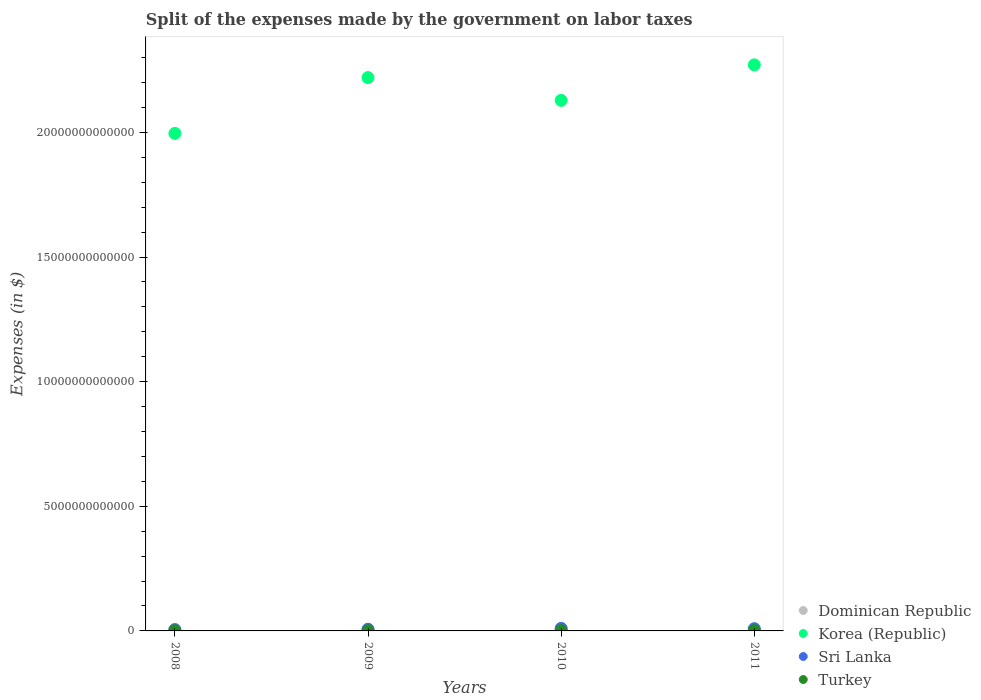Is the number of dotlines equal to the number of legend labels?
Keep it short and to the point. Yes. What is the expenses made by the government on labor taxes in Sri Lanka in 2010?
Your answer should be very brief. 1.03e+11. Across all years, what is the maximum expenses made by the government on labor taxes in Korea (Republic)?
Keep it short and to the point. 2.27e+13. Across all years, what is the minimum expenses made by the government on labor taxes in Turkey?
Offer a very short reply. 8.59e+09. In which year was the expenses made by the government on labor taxes in Dominican Republic maximum?
Provide a succinct answer. 2011. In which year was the expenses made by the government on labor taxes in Korea (Republic) minimum?
Offer a terse response. 2008. What is the total expenses made by the government on labor taxes in Korea (Republic) in the graph?
Provide a succinct answer. 8.62e+13. What is the difference between the expenses made by the government on labor taxes in Korea (Republic) in 2010 and that in 2011?
Provide a short and direct response. -1.42e+12. What is the difference between the expenses made by the government on labor taxes in Sri Lanka in 2011 and the expenses made by the government on labor taxes in Korea (Republic) in 2008?
Ensure brevity in your answer.  -1.99e+13. What is the average expenses made by the government on labor taxes in Dominican Republic per year?
Give a very brief answer. 1.30e+1. In the year 2010, what is the difference between the expenses made by the government on labor taxes in Korea (Republic) and expenses made by the government on labor taxes in Dominican Republic?
Provide a short and direct response. 2.13e+13. In how many years, is the expenses made by the government on labor taxes in Sri Lanka greater than 14000000000000 $?
Ensure brevity in your answer.  0. What is the ratio of the expenses made by the government on labor taxes in Sri Lanka in 2008 to that in 2009?
Offer a terse response. 0.78. Is the expenses made by the government on labor taxes in Korea (Republic) in 2009 less than that in 2011?
Offer a very short reply. Yes. What is the difference between the highest and the second highest expenses made by the government on labor taxes in Dominican Republic?
Your response must be concise. 2.41e+09. What is the difference between the highest and the lowest expenses made by the government on labor taxes in Sri Lanka?
Offer a terse response. 4.86e+1. Is it the case that in every year, the sum of the expenses made by the government on labor taxes in Sri Lanka and expenses made by the government on labor taxes in Dominican Republic  is greater than the sum of expenses made by the government on labor taxes in Korea (Republic) and expenses made by the government on labor taxes in Turkey?
Give a very brief answer. Yes. Is it the case that in every year, the sum of the expenses made by the government on labor taxes in Turkey and expenses made by the government on labor taxes in Sri Lanka  is greater than the expenses made by the government on labor taxes in Korea (Republic)?
Provide a succinct answer. No. Does the expenses made by the government on labor taxes in Turkey monotonically increase over the years?
Your answer should be very brief. No. How many dotlines are there?
Make the answer very short. 4. How many years are there in the graph?
Offer a very short reply. 4. What is the difference between two consecutive major ticks on the Y-axis?
Ensure brevity in your answer.  5.00e+12. Are the values on the major ticks of Y-axis written in scientific E-notation?
Make the answer very short. No. Does the graph contain any zero values?
Offer a terse response. No. How are the legend labels stacked?
Give a very brief answer. Vertical. What is the title of the graph?
Offer a very short reply. Split of the expenses made by the government on labor taxes. What is the label or title of the X-axis?
Your response must be concise. Years. What is the label or title of the Y-axis?
Provide a succinct answer. Expenses (in $). What is the Expenses (in $) in Dominican Republic in 2008?
Give a very brief answer. 1.22e+1. What is the Expenses (in $) in Korea (Republic) in 2008?
Offer a very short reply. 2.00e+13. What is the Expenses (in $) in Sri Lanka in 2008?
Your answer should be compact. 5.44e+1. What is the Expenses (in $) of Turkey in 2008?
Your response must be concise. 8.59e+09. What is the Expenses (in $) in Dominican Republic in 2009?
Your answer should be very brief. 1.09e+1. What is the Expenses (in $) of Korea (Republic) in 2009?
Ensure brevity in your answer.  2.22e+13. What is the Expenses (in $) of Sri Lanka in 2009?
Keep it short and to the point. 6.97e+1. What is the Expenses (in $) of Turkey in 2009?
Provide a succinct answer. 1.01e+1. What is the Expenses (in $) of Dominican Republic in 2010?
Offer a terse response. 1.32e+1. What is the Expenses (in $) of Korea (Republic) in 2010?
Ensure brevity in your answer.  2.13e+13. What is the Expenses (in $) in Sri Lanka in 2010?
Provide a short and direct response. 1.03e+11. What is the Expenses (in $) in Turkey in 2010?
Offer a very short reply. 1.50e+1. What is the Expenses (in $) of Dominican Republic in 2011?
Your response must be concise. 1.57e+1. What is the Expenses (in $) of Korea (Republic) in 2011?
Offer a very short reply. 2.27e+13. What is the Expenses (in $) in Sri Lanka in 2011?
Your response must be concise. 8.96e+1. What is the Expenses (in $) of Turkey in 2011?
Your answer should be compact. 1.15e+1. Across all years, what is the maximum Expenses (in $) in Dominican Republic?
Give a very brief answer. 1.57e+1. Across all years, what is the maximum Expenses (in $) of Korea (Republic)?
Your answer should be very brief. 2.27e+13. Across all years, what is the maximum Expenses (in $) in Sri Lanka?
Keep it short and to the point. 1.03e+11. Across all years, what is the maximum Expenses (in $) of Turkey?
Your answer should be compact. 1.50e+1. Across all years, what is the minimum Expenses (in $) of Dominican Republic?
Make the answer very short. 1.09e+1. Across all years, what is the minimum Expenses (in $) of Korea (Republic)?
Offer a very short reply. 2.00e+13. Across all years, what is the minimum Expenses (in $) of Sri Lanka?
Provide a succinct answer. 5.44e+1. Across all years, what is the minimum Expenses (in $) of Turkey?
Provide a short and direct response. 8.59e+09. What is the total Expenses (in $) of Dominican Republic in the graph?
Give a very brief answer. 5.20e+1. What is the total Expenses (in $) in Korea (Republic) in the graph?
Offer a very short reply. 8.62e+13. What is the total Expenses (in $) of Sri Lanka in the graph?
Offer a terse response. 3.17e+11. What is the total Expenses (in $) of Turkey in the graph?
Your answer should be very brief. 4.52e+1. What is the difference between the Expenses (in $) in Dominican Republic in 2008 and that in 2009?
Offer a very short reply. 1.29e+09. What is the difference between the Expenses (in $) of Korea (Republic) in 2008 and that in 2009?
Offer a very short reply. -2.24e+12. What is the difference between the Expenses (in $) of Sri Lanka in 2008 and that in 2009?
Your answer should be very brief. -1.53e+1. What is the difference between the Expenses (in $) in Turkey in 2008 and that in 2009?
Give a very brief answer. -1.55e+09. What is the difference between the Expenses (in $) of Dominican Republic in 2008 and that in 2010?
Offer a very short reply. -1.07e+09. What is the difference between the Expenses (in $) in Korea (Republic) in 2008 and that in 2010?
Offer a very short reply. -1.33e+12. What is the difference between the Expenses (in $) of Sri Lanka in 2008 and that in 2010?
Provide a short and direct response. -4.86e+1. What is the difference between the Expenses (in $) of Turkey in 2008 and that in 2010?
Provide a short and direct response. -6.39e+09. What is the difference between the Expenses (in $) in Dominican Republic in 2008 and that in 2011?
Your answer should be compact. -3.48e+09. What is the difference between the Expenses (in $) of Korea (Republic) in 2008 and that in 2011?
Give a very brief answer. -2.75e+12. What is the difference between the Expenses (in $) in Sri Lanka in 2008 and that in 2011?
Offer a terse response. -3.51e+1. What is the difference between the Expenses (in $) in Turkey in 2008 and that in 2011?
Offer a terse response. -2.95e+09. What is the difference between the Expenses (in $) of Dominican Republic in 2009 and that in 2010?
Your answer should be compact. -2.36e+09. What is the difference between the Expenses (in $) in Korea (Republic) in 2009 and that in 2010?
Your response must be concise. 9.15e+11. What is the difference between the Expenses (in $) of Sri Lanka in 2009 and that in 2010?
Provide a succinct answer. -3.33e+1. What is the difference between the Expenses (in $) of Turkey in 2009 and that in 2010?
Provide a succinct answer. -4.84e+09. What is the difference between the Expenses (in $) in Dominican Republic in 2009 and that in 2011?
Provide a succinct answer. -4.77e+09. What is the difference between the Expenses (in $) of Korea (Republic) in 2009 and that in 2011?
Make the answer very short. -5.10e+11. What is the difference between the Expenses (in $) of Sri Lanka in 2009 and that in 2011?
Keep it short and to the point. -1.98e+1. What is the difference between the Expenses (in $) in Turkey in 2009 and that in 2011?
Your answer should be very brief. -1.40e+09. What is the difference between the Expenses (in $) of Dominican Republic in 2010 and that in 2011?
Make the answer very short. -2.41e+09. What is the difference between the Expenses (in $) in Korea (Republic) in 2010 and that in 2011?
Your answer should be very brief. -1.42e+12. What is the difference between the Expenses (in $) of Sri Lanka in 2010 and that in 2011?
Provide a short and direct response. 1.35e+1. What is the difference between the Expenses (in $) in Turkey in 2010 and that in 2011?
Your answer should be compact. 3.44e+09. What is the difference between the Expenses (in $) of Dominican Republic in 2008 and the Expenses (in $) of Korea (Republic) in 2009?
Provide a succinct answer. -2.22e+13. What is the difference between the Expenses (in $) in Dominican Republic in 2008 and the Expenses (in $) in Sri Lanka in 2009?
Ensure brevity in your answer.  -5.76e+1. What is the difference between the Expenses (in $) of Dominican Republic in 2008 and the Expenses (in $) of Turkey in 2009?
Provide a short and direct response. 2.04e+09. What is the difference between the Expenses (in $) in Korea (Republic) in 2008 and the Expenses (in $) in Sri Lanka in 2009?
Offer a terse response. 1.99e+13. What is the difference between the Expenses (in $) in Korea (Republic) in 2008 and the Expenses (in $) in Turkey in 2009?
Your answer should be very brief. 2.00e+13. What is the difference between the Expenses (in $) of Sri Lanka in 2008 and the Expenses (in $) of Turkey in 2009?
Provide a succinct answer. 4.43e+1. What is the difference between the Expenses (in $) in Dominican Republic in 2008 and the Expenses (in $) in Korea (Republic) in 2010?
Ensure brevity in your answer.  -2.13e+13. What is the difference between the Expenses (in $) in Dominican Republic in 2008 and the Expenses (in $) in Sri Lanka in 2010?
Offer a terse response. -9.08e+1. What is the difference between the Expenses (in $) in Dominican Republic in 2008 and the Expenses (in $) in Turkey in 2010?
Offer a very short reply. -2.80e+09. What is the difference between the Expenses (in $) of Korea (Republic) in 2008 and the Expenses (in $) of Sri Lanka in 2010?
Make the answer very short. 1.99e+13. What is the difference between the Expenses (in $) of Korea (Republic) in 2008 and the Expenses (in $) of Turkey in 2010?
Give a very brief answer. 1.99e+13. What is the difference between the Expenses (in $) in Sri Lanka in 2008 and the Expenses (in $) in Turkey in 2010?
Make the answer very short. 3.95e+1. What is the difference between the Expenses (in $) in Dominican Republic in 2008 and the Expenses (in $) in Korea (Republic) in 2011?
Offer a terse response. -2.27e+13. What is the difference between the Expenses (in $) in Dominican Republic in 2008 and the Expenses (in $) in Sri Lanka in 2011?
Keep it short and to the point. -7.74e+1. What is the difference between the Expenses (in $) of Dominican Republic in 2008 and the Expenses (in $) of Turkey in 2011?
Make the answer very short. 6.41e+08. What is the difference between the Expenses (in $) in Korea (Republic) in 2008 and the Expenses (in $) in Sri Lanka in 2011?
Provide a succinct answer. 1.99e+13. What is the difference between the Expenses (in $) in Korea (Republic) in 2008 and the Expenses (in $) in Turkey in 2011?
Your answer should be compact. 1.99e+13. What is the difference between the Expenses (in $) of Sri Lanka in 2008 and the Expenses (in $) of Turkey in 2011?
Your answer should be very brief. 4.29e+1. What is the difference between the Expenses (in $) of Dominican Republic in 2009 and the Expenses (in $) of Korea (Republic) in 2010?
Provide a succinct answer. -2.13e+13. What is the difference between the Expenses (in $) of Dominican Republic in 2009 and the Expenses (in $) of Sri Lanka in 2010?
Your response must be concise. -9.21e+1. What is the difference between the Expenses (in $) of Dominican Republic in 2009 and the Expenses (in $) of Turkey in 2010?
Your answer should be very brief. -4.09e+09. What is the difference between the Expenses (in $) of Korea (Republic) in 2009 and the Expenses (in $) of Sri Lanka in 2010?
Your answer should be very brief. 2.21e+13. What is the difference between the Expenses (in $) of Korea (Republic) in 2009 and the Expenses (in $) of Turkey in 2010?
Your answer should be compact. 2.22e+13. What is the difference between the Expenses (in $) in Sri Lanka in 2009 and the Expenses (in $) in Turkey in 2010?
Make the answer very short. 5.48e+1. What is the difference between the Expenses (in $) of Dominican Republic in 2009 and the Expenses (in $) of Korea (Republic) in 2011?
Ensure brevity in your answer.  -2.27e+13. What is the difference between the Expenses (in $) in Dominican Republic in 2009 and the Expenses (in $) in Sri Lanka in 2011?
Your response must be concise. -7.87e+1. What is the difference between the Expenses (in $) of Dominican Republic in 2009 and the Expenses (in $) of Turkey in 2011?
Provide a succinct answer. -6.51e+08. What is the difference between the Expenses (in $) of Korea (Republic) in 2009 and the Expenses (in $) of Sri Lanka in 2011?
Offer a very short reply. 2.21e+13. What is the difference between the Expenses (in $) of Korea (Republic) in 2009 and the Expenses (in $) of Turkey in 2011?
Your response must be concise. 2.22e+13. What is the difference between the Expenses (in $) in Sri Lanka in 2009 and the Expenses (in $) in Turkey in 2011?
Keep it short and to the point. 5.82e+1. What is the difference between the Expenses (in $) in Dominican Republic in 2010 and the Expenses (in $) in Korea (Republic) in 2011?
Provide a short and direct response. -2.27e+13. What is the difference between the Expenses (in $) of Dominican Republic in 2010 and the Expenses (in $) of Sri Lanka in 2011?
Your answer should be very brief. -7.63e+1. What is the difference between the Expenses (in $) of Dominican Republic in 2010 and the Expenses (in $) of Turkey in 2011?
Keep it short and to the point. 1.71e+09. What is the difference between the Expenses (in $) in Korea (Republic) in 2010 and the Expenses (in $) in Sri Lanka in 2011?
Provide a succinct answer. 2.12e+13. What is the difference between the Expenses (in $) in Korea (Republic) in 2010 and the Expenses (in $) in Turkey in 2011?
Give a very brief answer. 2.13e+13. What is the difference between the Expenses (in $) of Sri Lanka in 2010 and the Expenses (in $) of Turkey in 2011?
Keep it short and to the point. 9.15e+1. What is the average Expenses (in $) in Dominican Republic per year?
Make the answer very short. 1.30e+1. What is the average Expenses (in $) in Korea (Republic) per year?
Give a very brief answer. 2.15e+13. What is the average Expenses (in $) in Sri Lanka per year?
Provide a succinct answer. 7.92e+1. What is the average Expenses (in $) in Turkey per year?
Offer a terse response. 1.13e+1. In the year 2008, what is the difference between the Expenses (in $) of Dominican Republic and Expenses (in $) of Korea (Republic)?
Provide a short and direct response. -1.99e+13. In the year 2008, what is the difference between the Expenses (in $) of Dominican Republic and Expenses (in $) of Sri Lanka?
Keep it short and to the point. -4.23e+1. In the year 2008, what is the difference between the Expenses (in $) of Dominican Republic and Expenses (in $) of Turkey?
Your response must be concise. 3.59e+09. In the year 2008, what is the difference between the Expenses (in $) of Korea (Republic) and Expenses (in $) of Sri Lanka?
Keep it short and to the point. 1.99e+13. In the year 2008, what is the difference between the Expenses (in $) in Korea (Republic) and Expenses (in $) in Turkey?
Provide a succinct answer. 2.00e+13. In the year 2008, what is the difference between the Expenses (in $) of Sri Lanka and Expenses (in $) of Turkey?
Offer a terse response. 4.59e+1. In the year 2009, what is the difference between the Expenses (in $) in Dominican Republic and Expenses (in $) in Korea (Republic)?
Provide a short and direct response. -2.22e+13. In the year 2009, what is the difference between the Expenses (in $) in Dominican Republic and Expenses (in $) in Sri Lanka?
Your response must be concise. -5.88e+1. In the year 2009, what is the difference between the Expenses (in $) of Dominican Republic and Expenses (in $) of Turkey?
Your answer should be compact. 7.47e+08. In the year 2009, what is the difference between the Expenses (in $) in Korea (Republic) and Expenses (in $) in Sri Lanka?
Provide a short and direct response. 2.21e+13. In the year 2009, what is the difference between the Expenses (in $) in Korea (Republic) and Expenses (in $) in Turkey?
Provide a succinct answer. 2.22e+13. In the year 2009, what is the difference between the Expenses (in $) in Sri Lanka and Expenses (in $) in Turkey?
Offer a terse response. 5.96e+1. In the year 2010, what is the difference between the Expenses (in $) in Dominican Republic and Expenses (in $) in Korea (Republic)?
Ensure brevity in your answer.  -2.13e+13. In the year 2010, what is the difference between the Expenses (in $) of Dominican Republic and Expenses (in $) of Sri Lanka?
Offer a very short reply. -8.98e+1. In the year 2010, what is the difference between the Expenses (in $) in Dominican Republic and Expenses (in $) in Turkey?
Your answer should be very brief. -1.73e+09. In the year 2010, what is the difference between the Expenses (in $) of Korea (Republic) and Expenses (in $) of Sri Lanka?
Keep it short and to the point. 2.12e+13. In the year 2010, what is the difference between the Expenses (in $) of Korea (Republic) and Expenses (in $) of Turkey?
Make the answer very short. 2.13e+13. In the year 2010, what is the difference between the Expenses (in $) of Sri Lanka and Expenses (in $) of Turkey?
Ensure brevity in your answer.  8.80e+1. In the year 2011, what is the difference between the Expenses (in $) of Dominican Republic and Expenses (in $) of Korea (Republic)?
Give a very brief answer. -2.27e+13. In the year 2011, what is the difference between the Expenses (in $) in Dominican Republic and Expenses (in $) in Sri Lanka?
Make the answer very short. -7.39e+1. In the year 2011, what is the difference between the Expenses (in $) of Dominican Republic and Expenses (in $) of Turkey?
Give a very brief answer. 4.12e+09. In the year 2011, what is the difference between the Expenses (in $) of Korea (Republic) and Expenses (in $) of Sri Lanka?
Keep it short and to the point. 2.26e+13. In the year 2011, what is the difference between the Expenses (in $) in Korea (Republic) and Expenses (in $) in Turkey?
Your answer should be compact. 2.27e+13. In the year 2011, what is the difference between the Expenses (in $) of Sri Lanka and Expenses (in $) of Turkey?
Ensure brevity in your answer.  7.80e+1. What is the ratio of the Expenses (in $) in Dominican Republic in 2008 to that in 2009?
Offer a terse response. 1.12. What is the ratio of the Expenses (in $) in Korea (Republic) in 2008 to that in 2009?
Give a very brief answer. 0.9. What is the ratio of the Expenses (in $) in Sri Lanka in 2008 to that in 2009?
Keep it short and to the point. 0.78. What is the ratio of the Expenses (in $) of Turkey in 2008 to that in 2009?
Offer a very short reply. 0.85. What is the ratio of the Expenses (in $) of Dominican Republic in 2008 to that in 2010?
Ensure brevity in your answer.  0.92. What is the ratio of the Expenses (in $) in Korea (Republic) in 2008 to that in 2010?
Offer a very short reply. 0.94. What is the ratio of the Expenses (in $) in Sri Lanka in 2008 to that in 2010?
Your answer should be compact. 0.53. What is the ratio of the Expenses (in $) of Turkey in 2008 to that in 2010?
Ensure brevity in your answer.  0.57. What is the ratio of the Expenses (in $) in Dominican Republic in 2008 to that in 2011?
Offer a very short reply. 0.78. What is the ratio of the Expenses (in $) of Korea (Republic) in 2008 to that in 2011?
Your answer should be very brief. 0.88. What is the ratio of the Expenses (in $) in Sri Lanka in 2008 to that in 2011?
Offer a terse response. 0.61. What is the ratio of the Expenses (in $) of Turkey in 2008 to that in 2011?
Offer a very short reply. 0.74. What is the ratio of the Expenses (in $) in Dominican Republic in 2009 to that in 2010?
Provide a short and direct response. 0.82. What is the ratio of the Expenses (in $) of Korea (Republic) in 2009 to that in 2010?
Provide a succinct answer. 1.04. What is the ratio of the Expenses (in $) in Sri Lanka in 2009 to that in 2010?
Keep it short and to the point. 0.68. What is the ratio of the Expenses (in $) of Turkey in 2009 to that in 2010?
Ensure brevity in your answer.  0.68. What is the ratio of the Expenses (in $) in Dominican Republic in 2009 to that in 2011?
Keep it short and to the point. 0.7. What is the ratio of the Expenses (in $) of Korea (Republic) in 2009 to that in 2011?
Your answer should be very brief. 0.98. What is the ratio of the Expenses (in $) of Sri Lanka in 2009 to that in 2011?
Ensure brevity in your answer.  0.78. What is the ratio of the Expenses (in $) in Turkey in 2009 to that in 2011?
Ensure brevity in your answer.  0.88. What is the ratio of the Expenses (in $) in Dominican Republic in 2010 to that in 2011?
Your answer should be compact. 0.85. What is the ratio of the Expenses (in $) in Korea (Republic) in 2010 to that in 2011?
Provide a succinct answer. 0.94. What is the ratio of the Expenses (in $) of Sri Lanka in 2010 to that in 2011?
Make the answer very short. 1.15. What is the ratio of the Expenses (in $) in Turkey in 2010 to that in 2011?
Ensure brevity in your answer.  1.3. What is the difference between the highest and the second highest Expenses (in $) of Dominican Republic?
Provide a short and direct response. 2.41e+09. What is the difference between the highest and the second highest Expenses (in $) in Korea (Republic)?
Provide a short and direct response. 5.10e+11. What is the difference between the highest and the second highest Expenses (in $) of Sri Lanka?
Offer a very short reply. 1.35e+1. What is the difference between the highest and the second highest Expenses (in $) of Turkey?
Keep it short and to the point. 3.44e+09. What is the difference between the highest and the lowest Expenses (in $) of Dominican Republic?
Provide a short and direct response. 4.77e+09. What is the difference between the highest and the lowest Expenses (in $) of Korea (Republic)?
Give a very brief answer. 2.75e+12. What is the difference between the highest and the lowest Expenses (in $) in Sri Lanka?
Keep it short and to the point. 4.86e+1. What is the difference between the highest and the lowest Expenses (in $) of Turkey?
Your answer should be compact. 6.39e+09. 